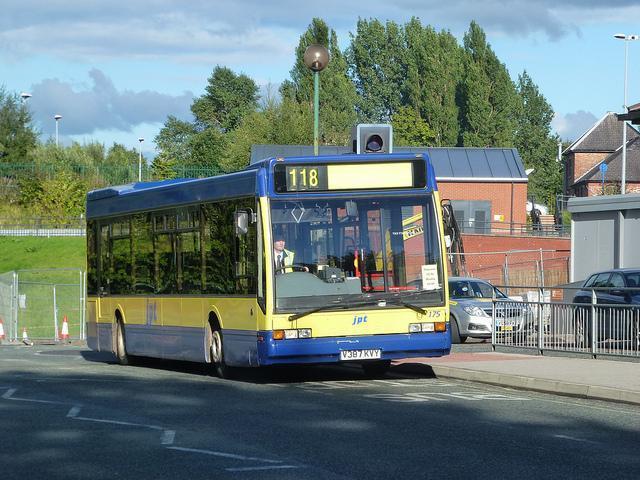How many thin striped kites are flying in the air?
Give a very brief answer. 0. 